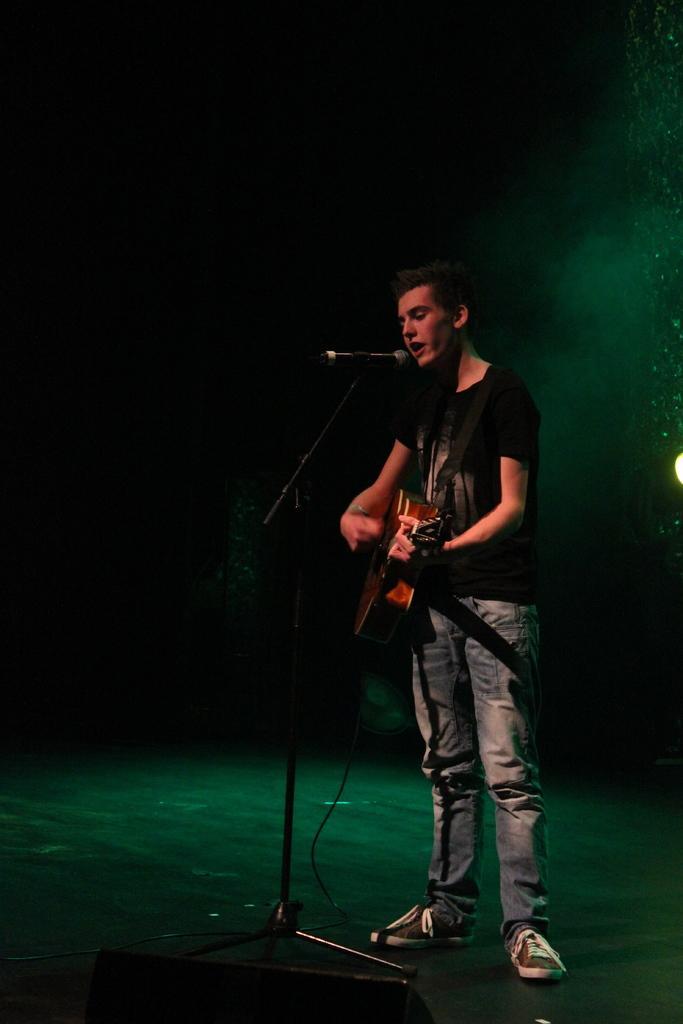Please provide a concise description of this image. In the picture we can see a man standing and playing a musical instrument and singing a song in the microphone which is on the stand and he is in black T-shirt and behind him we can see dark. 